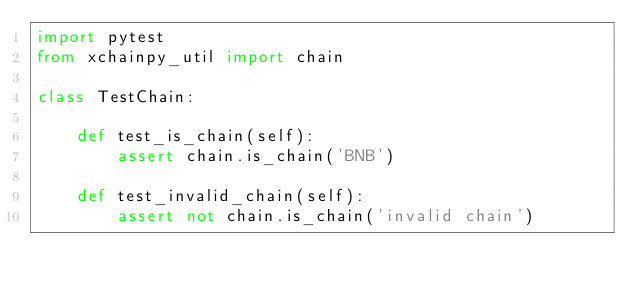Convert code to text. <code><loc_0><loc_0><loc_500><loc_500><_Python_>import pytest
from xchainpy_util import chain

class TestChain:

    def test_is_chain(self):
        assert chain.is_chain('BNB')

    def test_invalid_chain(self):
        assert not chain.is_chain('invalid chain')</code> 